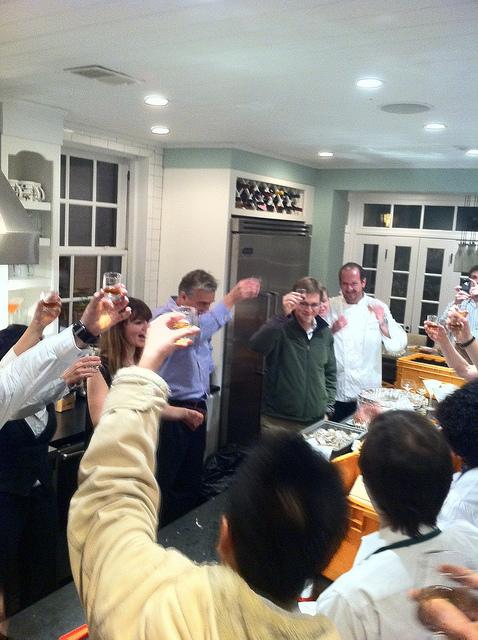Animals raising objects?
Be succinct. No. Is it dark outside?
Concise answer only. Yes. Are these people eating toast or making a toast?
Keep it brief. Making toast. 